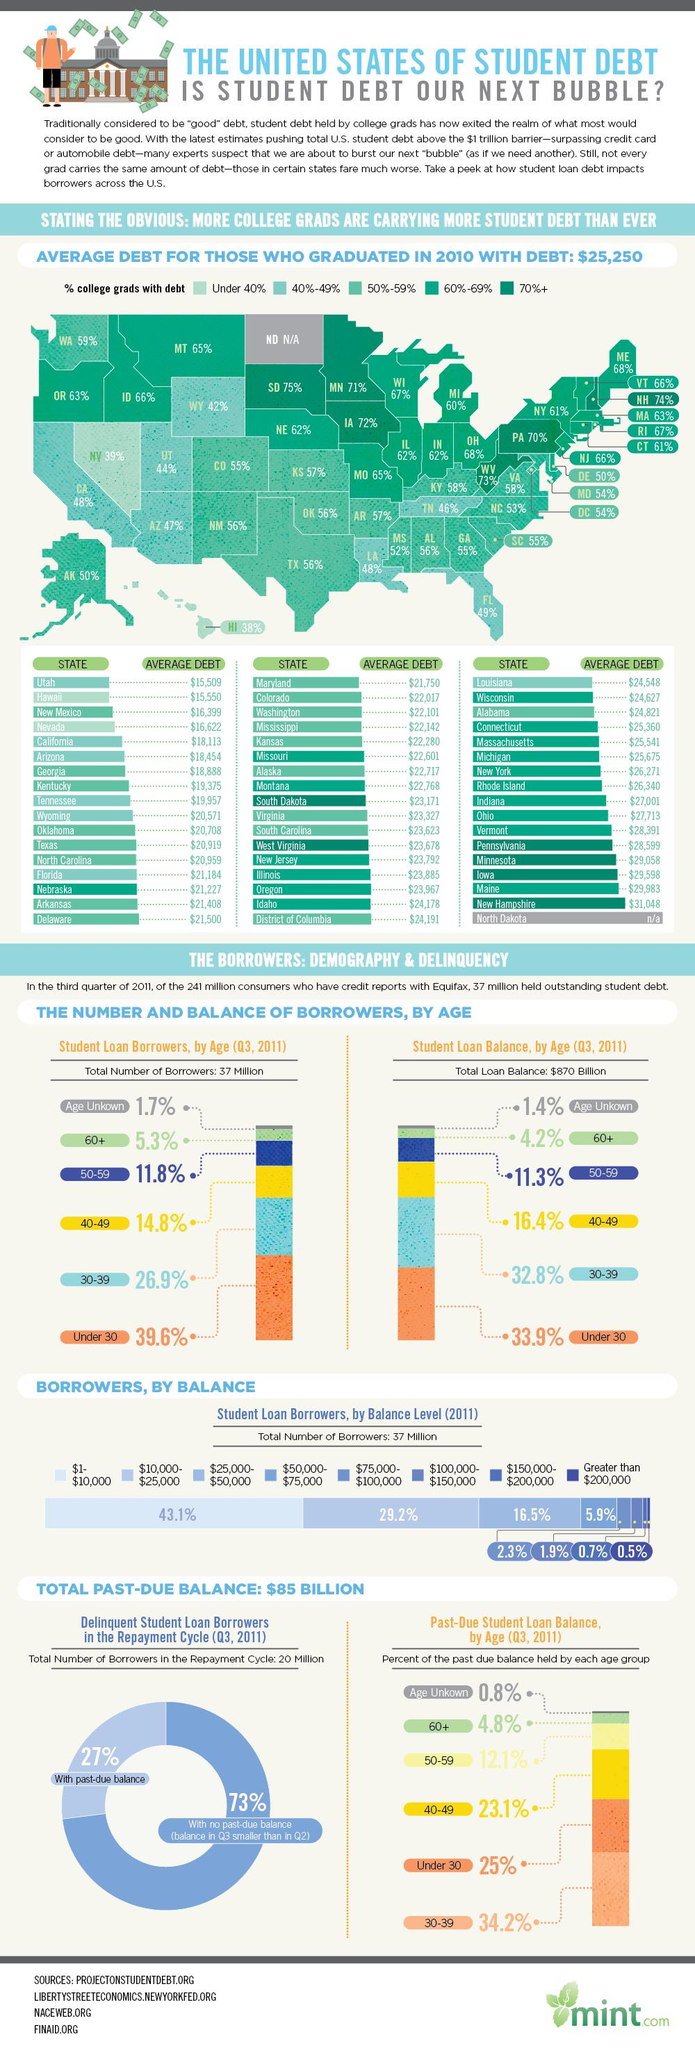Specify some key components in this picture. Utah is the state in the United States that has the least average debt for individuals who graduated in 2010. According to data from 2010, the state in the United States with the highest average debt for individuals who graduated is New Hampshire. In 2011, the past due student loan balance held by the age group of 60+ was 4.8%. In 2011, the total student loan balance in the United States was approximately $870 billion. According to data, about 26.9% of student loan borrowers in the United States are between the ages of 30 and 39. 